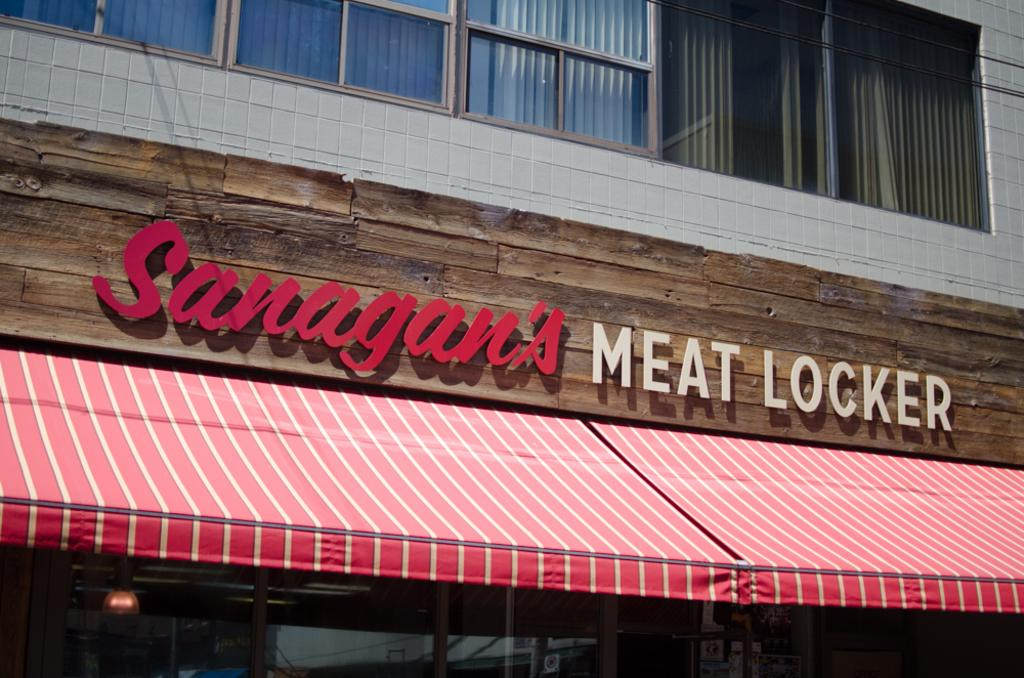What is the main subject of the image? The main subject of the image is a building. Can you describe the building in the image? The building has windows. What else can be seen at the bottom of the image? There is a store at the bottom of the image. What type of mark can be seen on the car in the image? There is no car present in the image, so no mark can be observed. 